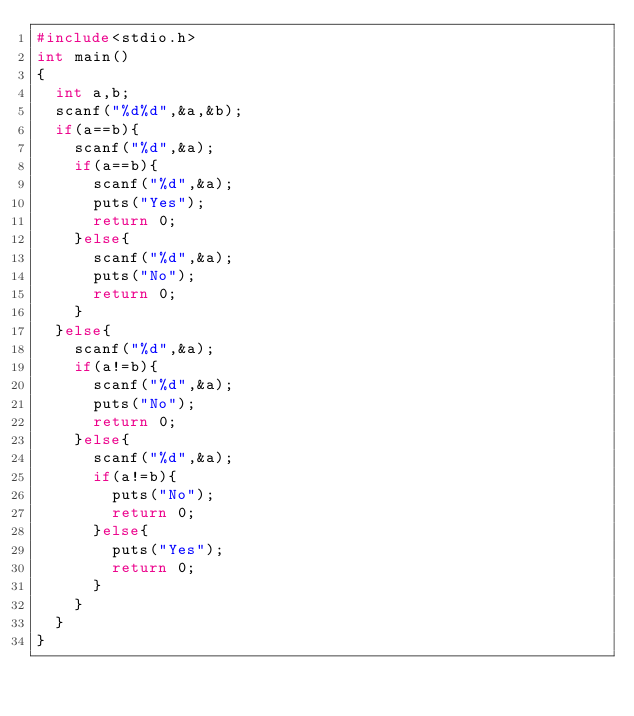<code> <loc_0><loc_0><loc_500><loc_500><_C_>#include<stdio.h>
int main()
{
  int a,b;
  scanf("%d%d",&a,&b);
  if(a==b){
    scanf("%d",&a);
    if(a==b){
      scanf("%d",&a);
      puts("Yes");
      return 0;
    }else{
      scanf("%d",&a);
      puts("No");
      return 0;
    }
  }else{
    scanf("%d",&a);
    if(a!=b){
      scanf("%d",&a);
      puts("No");
      return 0;
    }else{
      scanf("%d",&a);
      if(a!=b){
        puts("No");
        return 0;
      }else{
        puts("Yes");
        return 0;
      }
    }
  }
}
      </code> 